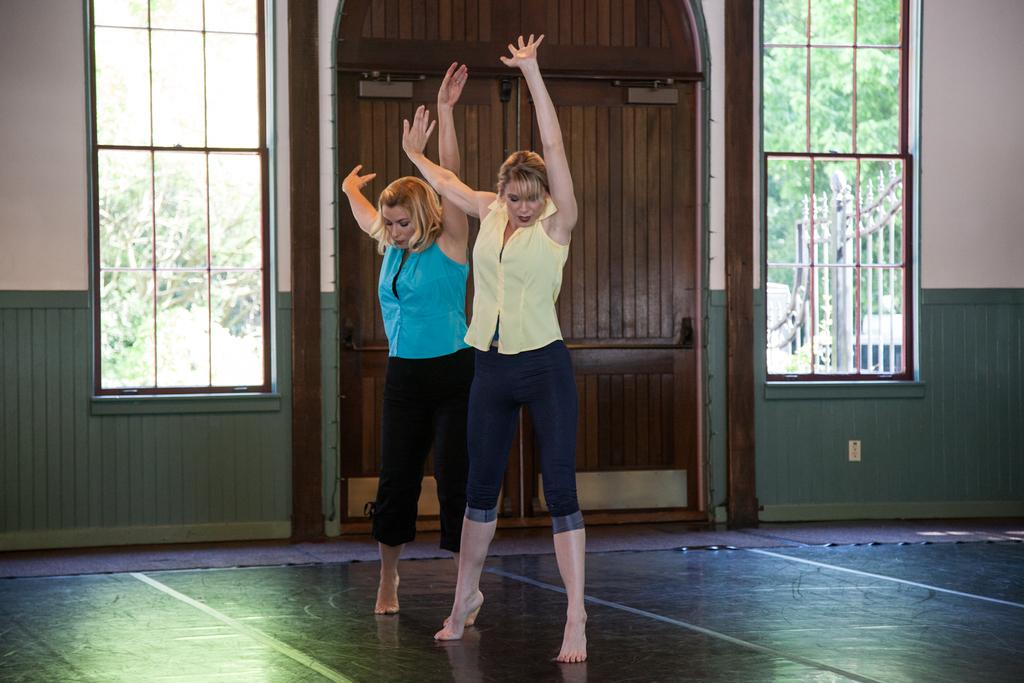How many people are in the image? There are two women in the image. What are the women doing in the image? The women are standing. What type of objects can be seen in the image? There are metal rods visible in the image. What can be seen in the background of the image? There are trees in the background of the image. What date is marked on the calendar in the image? There is no calendar present in the image. What type of legal advice is the lawyer providing in the image? There is no lawyer present in the image. 